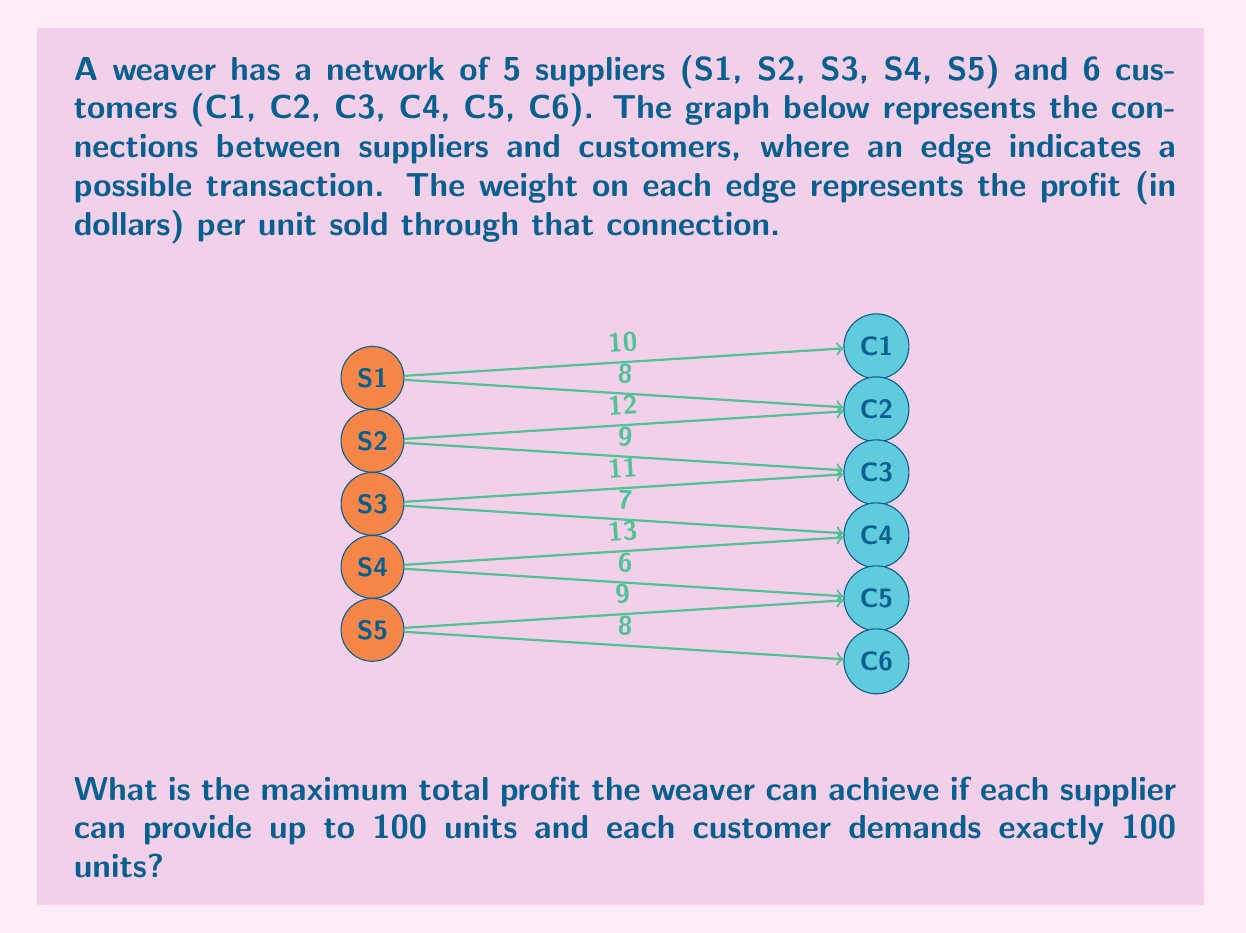Show me your answer to this math problem. To solve this problem, we need to use the concept of maximum bipartite matching with weights. Here's a step-by-step approach:

1) First, we need to identify the optimal matching for each customer:
   C1: S1 (10)
   C2: S1 (8) or S2 (12) - choose S2
   C3: S2 (9) or S3 (11) - choose S3
   C4: S3 (7) or S4 (13) - choose S4
   C5: S4 (6) or S5 (9) - choose S5
   C6: S5 (8)

2) Now, we can calculate the profit for each optimal match:
   S1 -> C1: 100 * $10 = $1000
   S2 -> C2: 100 * $12 = $1200
   S3 -> C3: 100 * $11 = $1100
   S4 -> C4: 100 * $13 = $1300
   S5 -> C5: 100 * $9 = $900
   S5 -> C6: 100 * $8 = $800 (using remaining capacity of S5)

3) Sum up all the profits:
   $$1000 + 1200 + 1100 + 1300 + 900 + 800 = 6300$$

Therefore, the maximum total profit the weaver can achieve is $6300.

This solution ensures that:
- Each supplier provides at most 100 units (S5 provides 200 units in total, split between C5 and C6)
- Each customer receives exactly 100 units
- The profit is maximized by choosing the highest-weight edges possible
Answer: $6300 